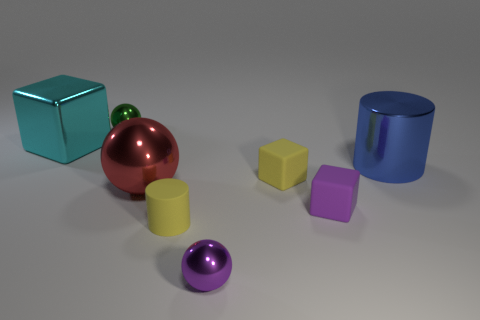There is a large red metal sphere; what number of green shiny spheres are right of it? 0 